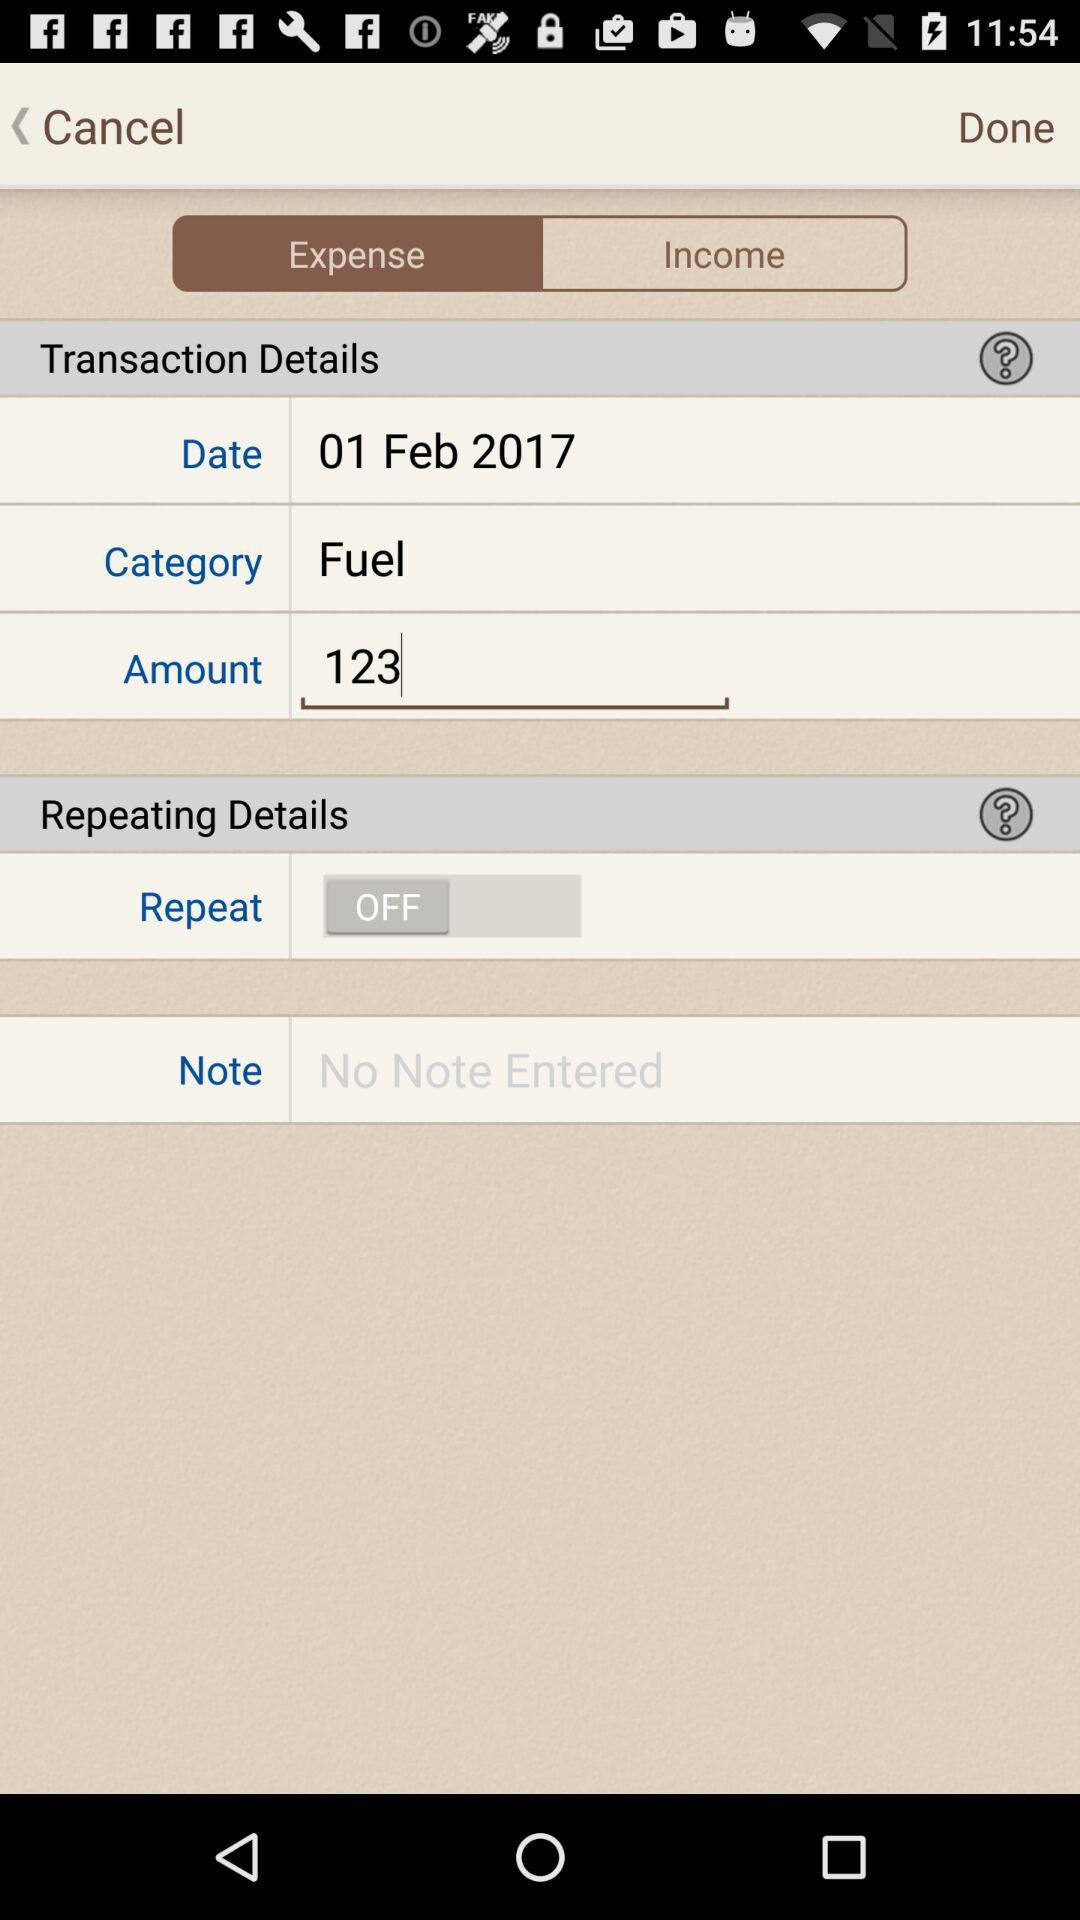How much does the transaction amount to?
Answer the question using a single word or phrase. 123 